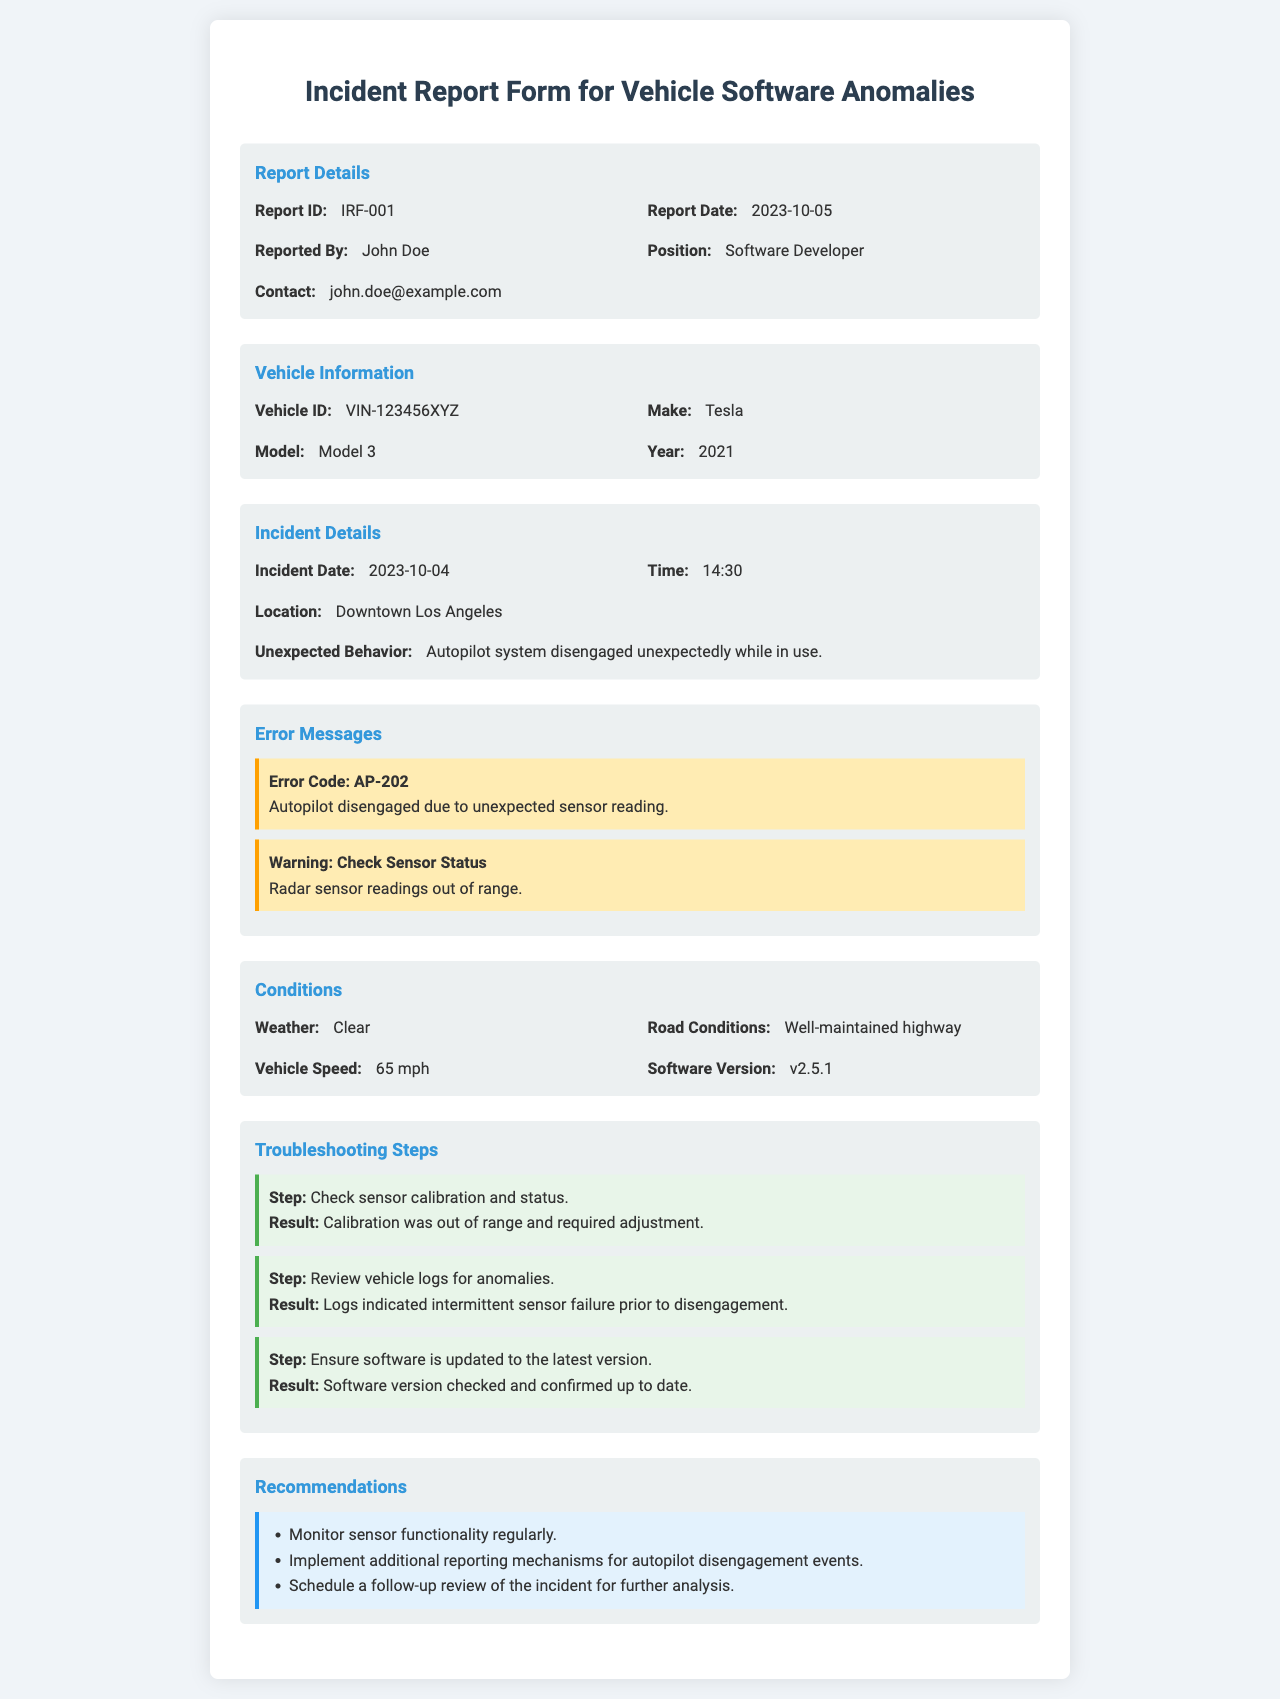what is the Report ID? The Report ID is a unique identifier for the incident report, listed in the report details section.
Answer: IRF-001 who reported the incident? This question pertains to the individual who submitted the report, mentioned in the report details section.
Answer: John Doe what is the Vehicle ID? The Vehicle ID is a unique identifier for the vehicle involved in the incident, found in the vehicle information section.
Answer: VIN-123456XYZ when did the incident occur? This refers to the exact date the incident took place, highlighted in the incident details section.
Answer: 2023-10-04 what was the unexpected behavior reported? This identifies the specific issue experienced by the vehicle, outlined in the incident details section.
Answer: Autopilot system disengaged unexpectedly while in use which error code was recorded? This question asks for the specific error code associated with the incident as mentioned in the error messages section.
Answer: AP-202 what was the vehicle speed at the time of the incident? The vehicle speed is a crucial detail from the conditions section that provides context for the incident.
Answer: 65 mph what recommendation is made regarding sensor monitoring? This question targets a specific recommendation provided in the recommendations section related to sensor maintenance.
Answer: Monitor sensor functionality regularly what troubleshooting step involved reviewing vehicle logs? This question requires knowledge of a certain step taken to resolve the issue as listed in the troubleshooting steps section.
Answer: Review vehicle logs for anomalies 